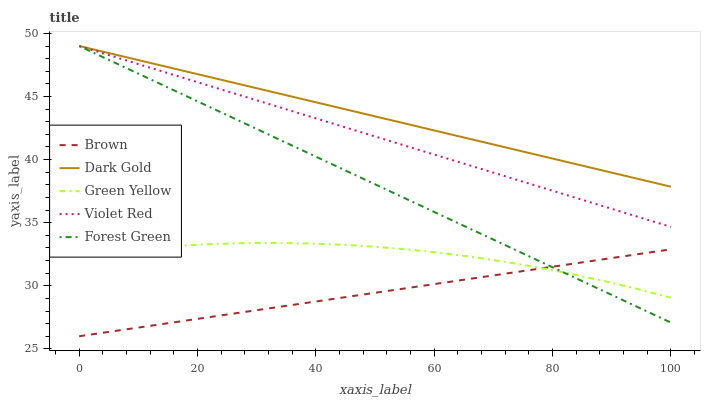Does Brown have the minimum area under the curve?
Answer yes or no. Yes. Does Dark Gold have the maximum area under the curve?
Answer yes or no. Yes. Does Violet Red have the minimum area under the curve?
Answer yes or no. No. Does Violet Red have the maximum area under the curve?
Answer yes or no. No. Is Violet Red the smoothest?
Answer yes or no. Yes. Is Green Yellow the roughest?
Answer yes or no. Yes. Is Green Yellow the smoothest?
Answer yes or no. No. Is Violet Red the roughest?
Answer yes or no. No. Does Brown have the lowest value?
Answer yes or no. Yes. Does Violet Red have the lowest value?
Answer yes or no. No. Does Dark Gold have the highest value?
Answer yes or no. Yes. Does Green Yellow have the highest value?
Answer yes or no. No. Is Green Yellow less than Dark Gold?
Answer yes or no. Yes. Is Dark Gold greater than Green Yellow?
Answer yes or no. Yes. Does Forest Green intersect Brown?
Answer yes or no. Yes. Is Forest Green less than Brown?
Answer yes or no. No. Is Forest Green greater than Brown?
Answer yes or no. No. Does Green Yellow intersect Dark Gold?
Answer yes or no. No. 